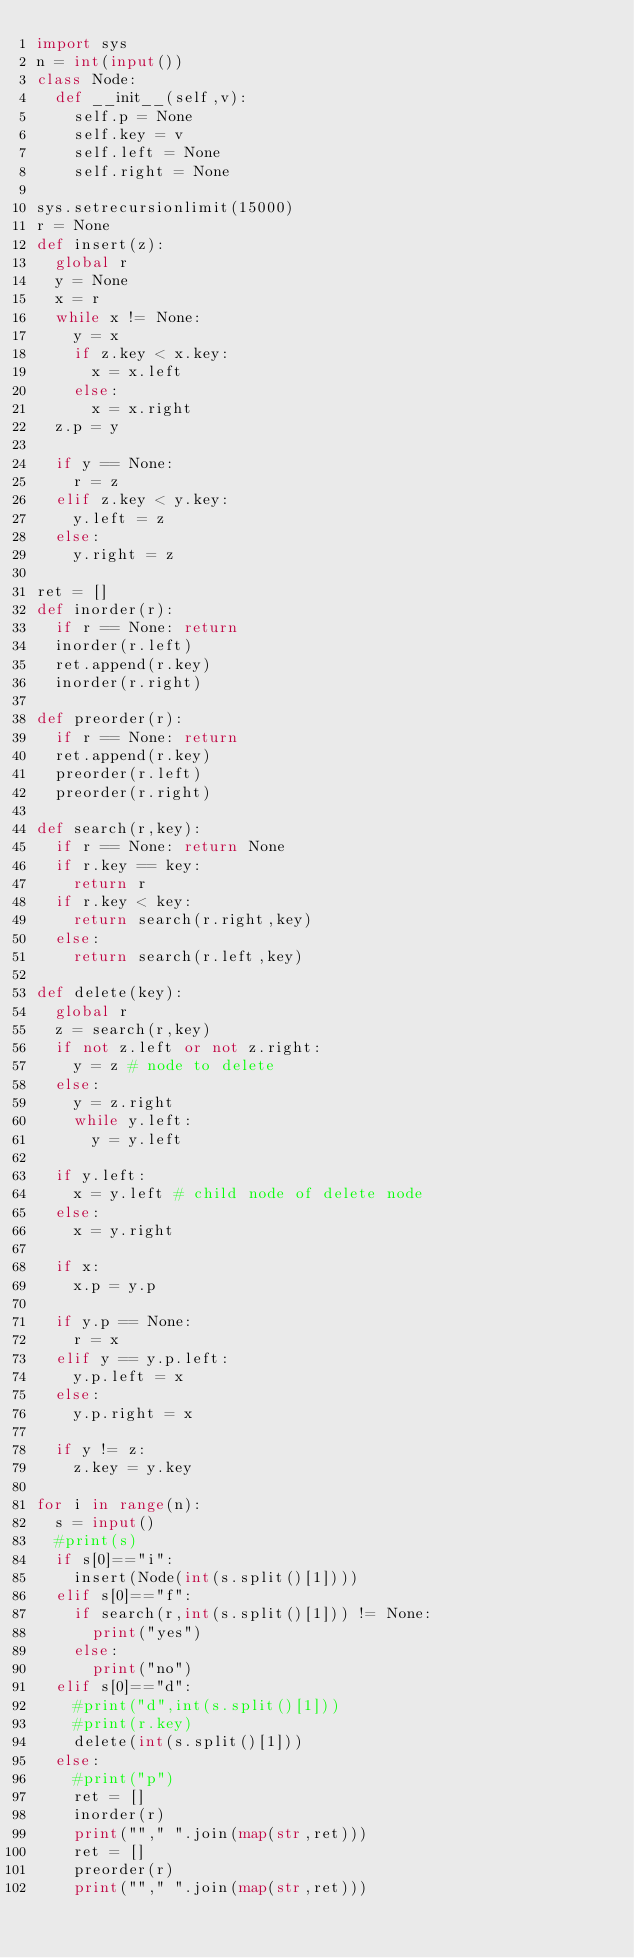<code> <loc_0><loc_0><loc_500><loc_500><_Python_>import sys
n = int(input())
class Node:
  def __init__(self,v):
    self.p = None
    self.key = v
    self.left = None
    self.right = None

sys.setrecursionlimit(15000)
r = None
def insert(z):
  global r
  y = None
  x = r
  while x != None:
    y = x
    if z.key < x.key:
      x = x.left
    else:
      x = x.right
  z.p = y

  if y == None:
    r = z
  elif z.key < y.key:
    y.left = z
  else:
    y.right = z

ret = []
def inorder(r):
  if r == None: return
  inorder(r.left)
  ret.append(r.key)
  inorder(r.right)

def preorder(r):
  if r == None: return
  ret.append(r.key)
  preorder(r.left)
  preorder(r.right)

def search(r,key):
  if r == None: return None
  if r.key == key:
    return r
  if r.key < key:
    return search(r.right,key)
  else:
    return search(r.left,key)

def delete(key):
  global r
  z = search(r,key)
  if not z.left or not z.right:
    y = z # node to delete
  else:
    y = z.right
    while y.left:
      y = y.left

  if y.left:
    x = y.left # child node of delete node
  else:
    x = y.right

  if x:
    x.p = y.p

  if y.p == None:
    r = x
  elif y == y.p.left:
    y.p.left = x
  else:
    y.p.right = x

  if y != z:
    z.key = y.key

for i in range(n):
  s = input()
  #print(s)
  if s[0]=="i":
    insert(Node(int(s.split()[1])))
  elif s[0]=="f":
    if search(r,int(s.split()[1])) != None:
      print("yes")
    else:
      print("no")
  elif s[0]=="d":
    #print("d",int(s.split()[1]))
    #print(r.key)
    delete(int(s.split()[1]))
  else:
    #print("p")
    ret = []
    inorder(r)
    print(""," ".join(map(str,ret)))
    ret = []
    preorder(r)
    print(""," ".join(map(str,ret)))

</code> 